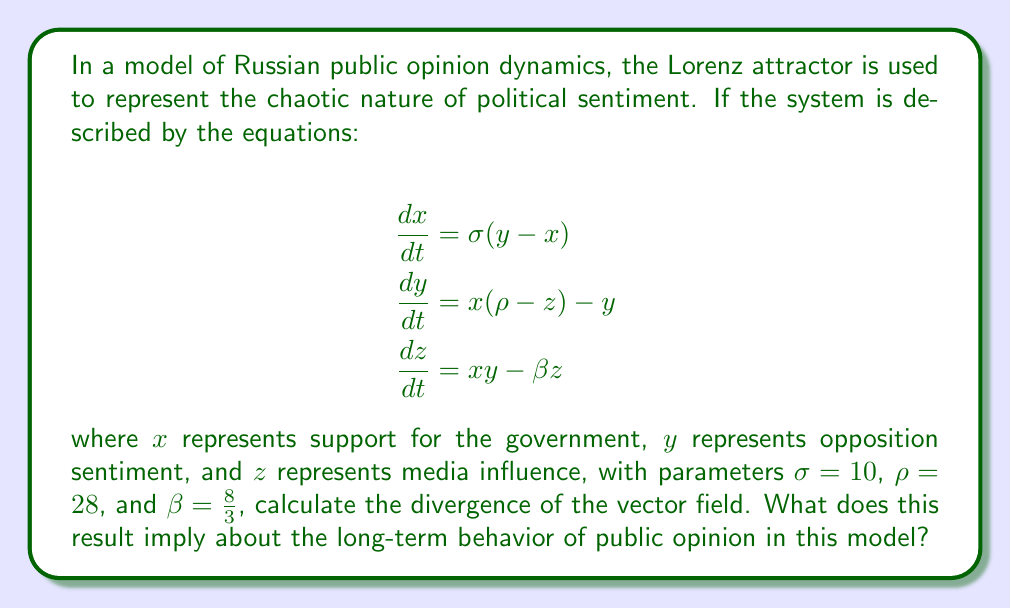Can you answer this question? To solve this problem, we need to follow these steps:

1) The divergence of a vector field $\mathbf{F}(x, y, z) = (F_1, F_2, F_3)$ is given by:

   $$\nabla \cdot \mathbf{F} = \frac{\partial F_1}{\partial x} + \frac{\partial F_2}{\partial y} + \frac{\partial F_3}{\partial z}$$

2) In our case, 
   $F_1 = \sigma(y-x)$
   $F_2 = x(\rho-z) - y$
   $F_3 = xy - \beta z$

3) Let's calculate each partial derivative:

   $\frac{\partial F_1}{\partial x} = -\sigma$
   
   $\frac{\partial F_2}{\partial y} = -1$
   
   $\frac{\partial F_3}{\partial z} = -\beta$

4) Now, we can sum these partial derivatives:

   $$\nabla \cdot \mathbf{F} = -\sigma - 1 - \beta$$

5) Substituting the given values:

   $$\nabla \cdot \mathbf{F} = -10 - 1 - \frac{8}{3} = -\frac{41}{3}$$

6) The divergence is negative, which implies that the volume in phase space contracts over time. In the context of the Lorenz attractor, this means that trajectories are pulled towards a strange attractor.

7) For public opinion dynamics, this suggests that despite the chaotic nature of the system, there are underlying patterns or "attractors" that opinion tends to gravitate towards over time. These could represent recurring themes or cyclical patterns in public sentiment, even if the exact state is unpredictable.
Answer: $-\frac{41}{3}$; implies contraction towards strange attractor 